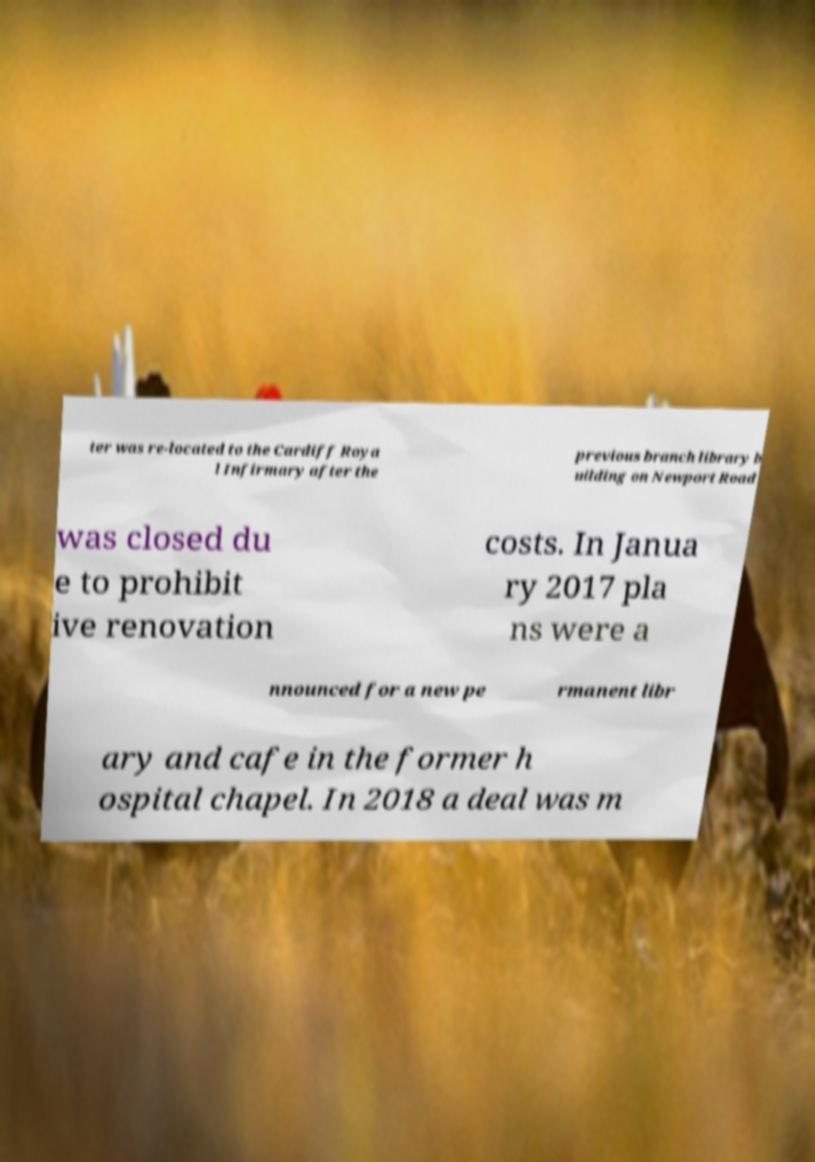For documentation purposes, I need the text within this image transcribed. Could you provide that? ter was re-located to the Cardiff Roya l Infirmary after the previous branch library b uilding on Newport Road was closed du e to prohibit ive renovation costs. In Janua ry 2017 pla ns were a nnounced for a new pe rmanent libr ary and cafe in the former h ospital chapel. In 2018 a deal was m 